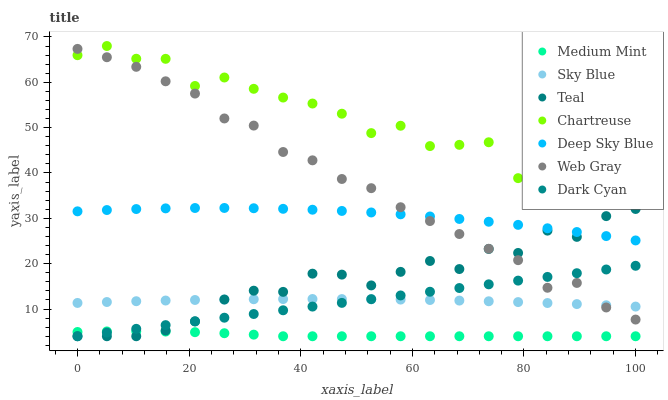Does Medium Mint have the minimum area under the curve?
Answer yes or no. Yes. Does Chartreuse have the maximum area under the curve?
Answer yes or no. Yes. Does Web Gray have the minimum area under the curve?
Answer yes or no. No. Does Web Gray have the maximum area under the curve?
Answer yes or no. No. Is Dark Cyan the smoothest?
Answer yes or no. Yes. Is Chartreuse the roughest?
Answer yes or no. Yes. Is Web Gray the smoothest?
Answer yes or no. No. Is Web Gray the roughest?
Answer yes or no. No. Does Medium Mint have the lowest value?
Answer yes or no. Yes. Does Web Gray have the lowest value?
Answer yes or no. No. Does Chartreuse have the highest value?
Answer yes or no. Yes. Does Web Gray have the highest value?
Answer yes or no. No. Is Teal less than Chartreuse?
Answer yes or no. Yes. Is Deep Sky Blue greater than Sky Blue?
Answer yes or no. Yes. Does Dark Cyan intersect Teal?
Answer yes or no. Yes. Is Dark Cyan less than Teal?
Answer yes or no. No. Is Dark Cyan greater than Teal?
Answer yes or no. No. Does Teal intersect Chartreuse?
Answer yes or no. No. 